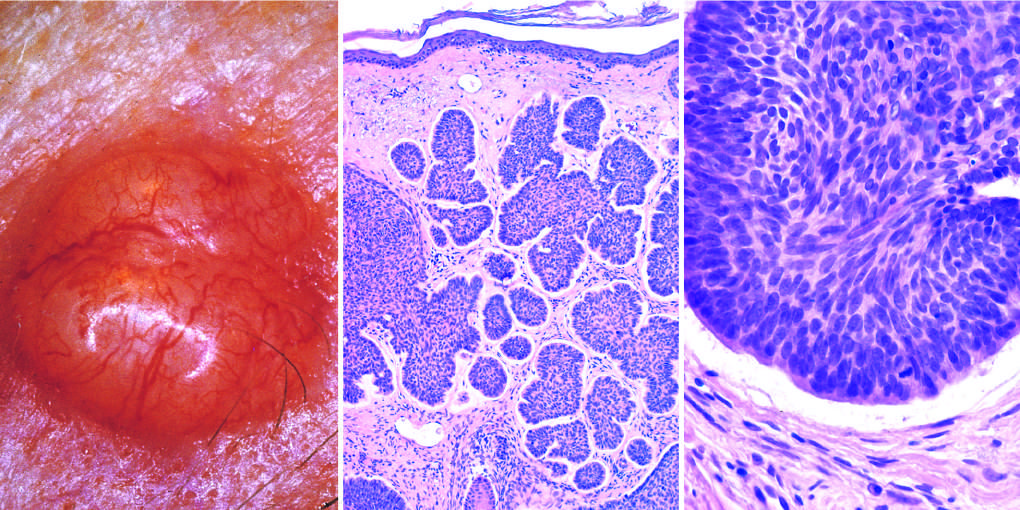s sectioning of ovary composed of nests of basaloid cells infiltrating a fibrotic stroma?
Answer the question using a single word or phrase. No 